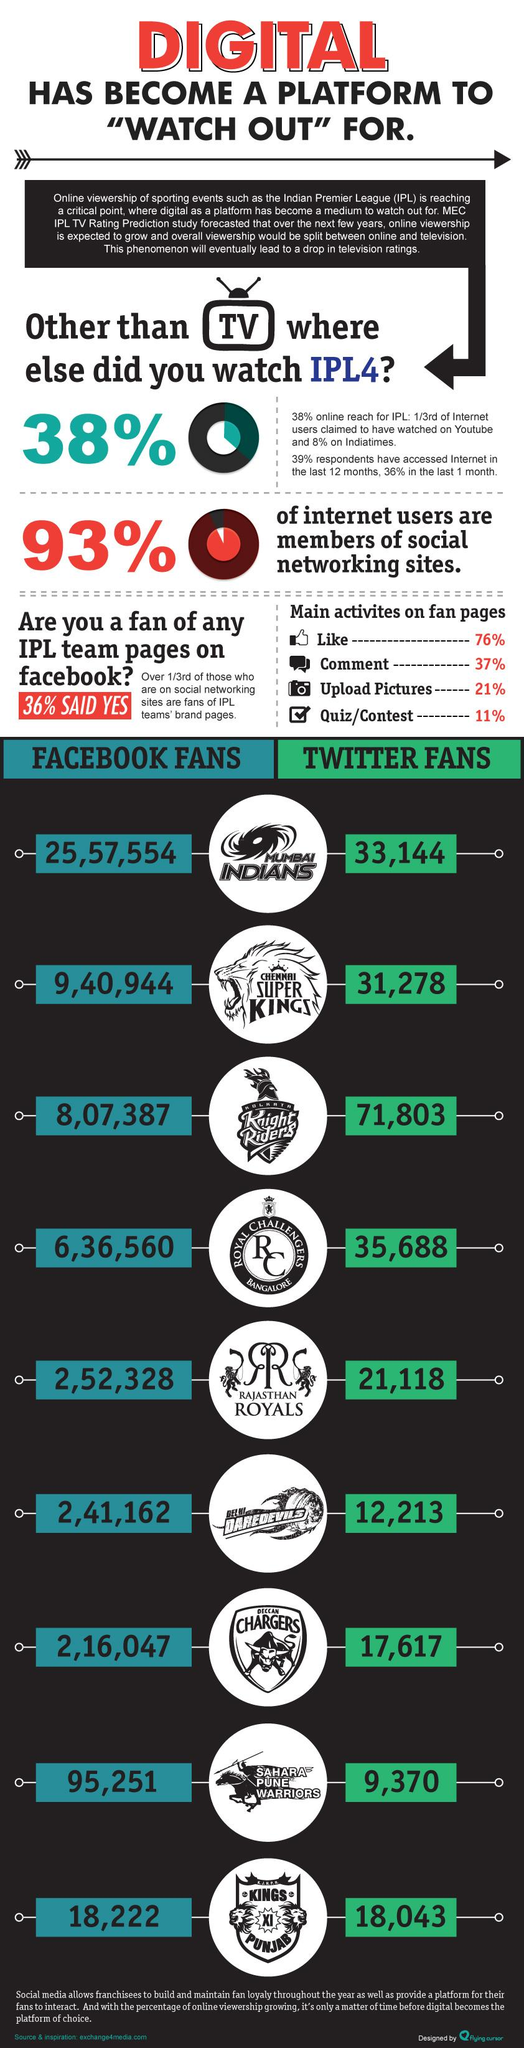Identify some key points in this picture. The percentage of uploaded pictures and quizzes taken together is 32%. The total number of Mumbai Indians fans on Facebook and Twitter is approximately 2590698. There are a total of 972,222 Chennai Super Kings fans on Facebook and Twitter combined. The combined percentage of likes and comments is 113%. According to the latest statistics, the total number of fans of the Kolkata Knight Riders on Facebook and Twitter is 879190. 